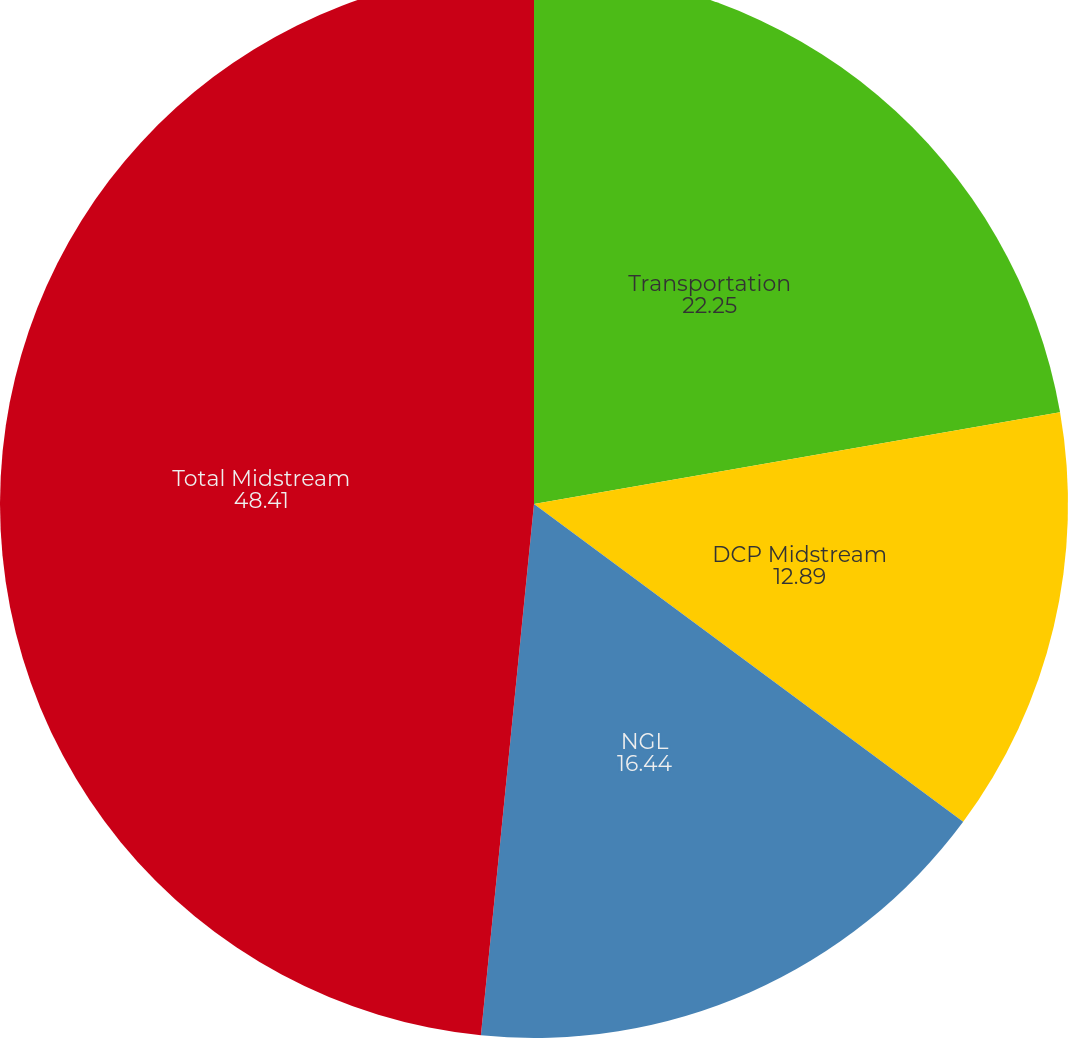Convert chart to OTSL. <chart><loc_0><loc_0><loc_500><loc_500><pie_chart><fcel>Transportation<fcel>DCP Midstream<fcel>NGL<fcel>Total Midstream<nl><fcel>22.25%<fcel>12.89%<fcel>16.44%<fcel>48.41%<nl></chart> 